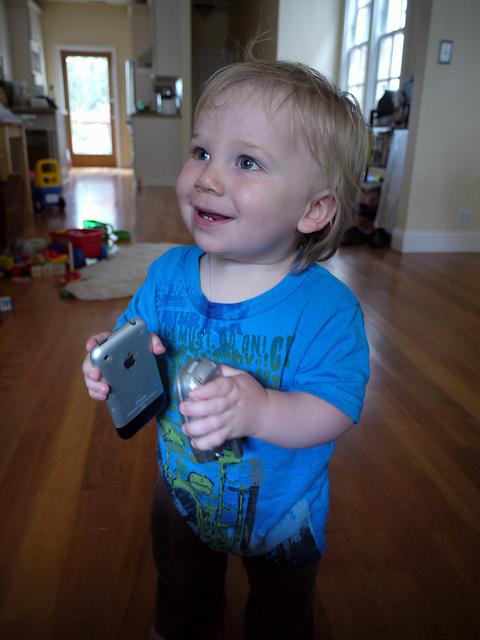Does this room have hardwood floors?
Answer briefly. Yes. Is the baby wearing pink?
Answer briefly. No. What ethnicity is this child?
Concise answer only. Caucasian. Is the baby happy?
Concise answer only. Yes. 